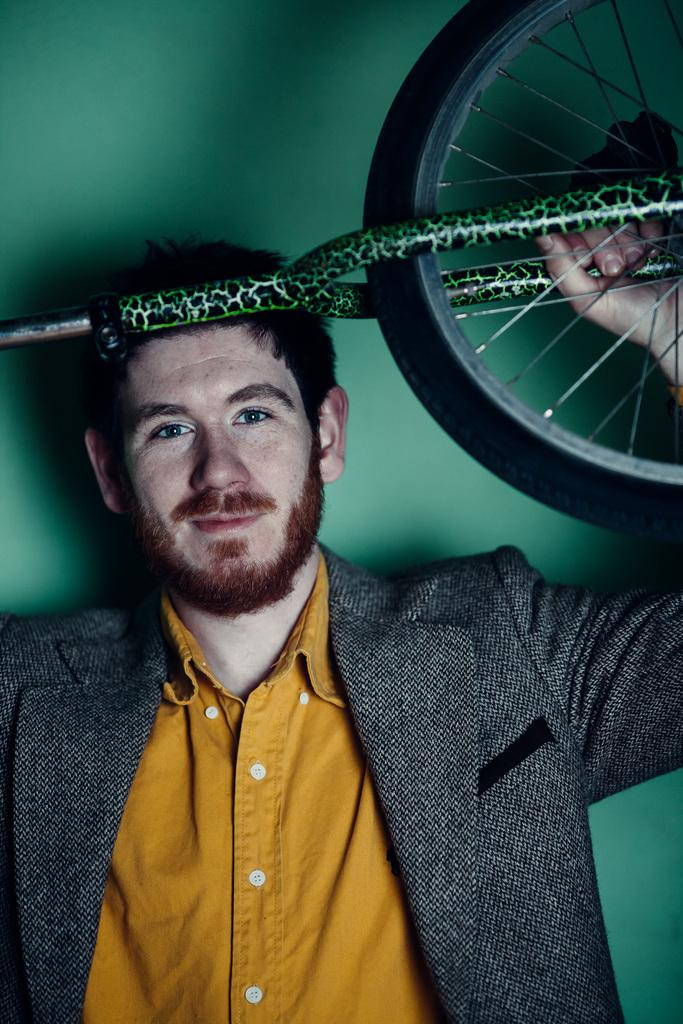Who is present in the image? There is a man in the image. What is the man holding in the image? The man is holding a bicycle. What color or type of environment is visible in the background of the image? The background of the image is green. What type of pain is the man experiencing in the image? There is no indication of pain in the image; the man is holding a bicycle. How many roses can be seen in the image? There are no roses present in the image. 